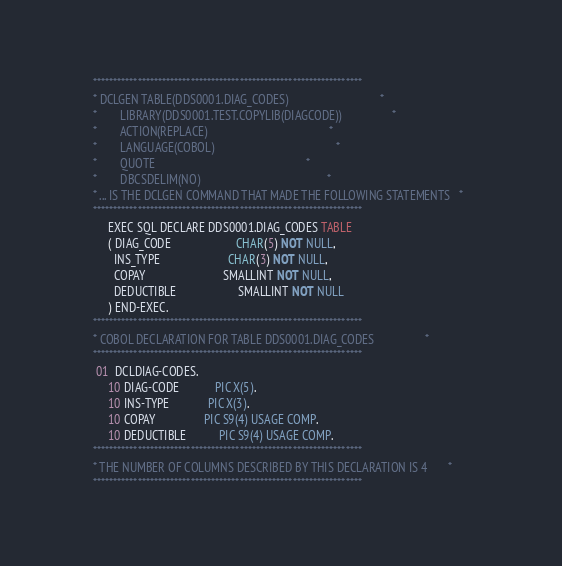<code> <loc_0><loc_0><loc_500><loc_500><_COBOL_>      ******************************************************************        
      * DCLGEN TABLE(DDS0001.DIAG_CODES)                               *        
      *        LIBRARY(DDS0001.TEST.COPYLIB(DIAGCODE))                 *        
      *        ACTION(REPLACE)                                         *        
      *        LANGUAGE(COBOL)                                         *        
      *        QUOTE                                                   *        
      *        DBCSDELIM(NO)                                           *        
      * ... IS THE DCLGEN COMMAND THAT MADE THE FOLLOWING STATEMENTS   *        
      ******************************************************************        
           EXEC SQL DECLARE DDS0001.DIAG_CODES TABLE                            
           ( DIAG_CODE                      CHAR(5) NOT NULL,                   
             INS_TYPE                       CHAR(3) NOT NULL,                   
             COPAY                          SMALLINT NOT NULL,                  
             DEDUCTIBLE                     SMALLINT NOT NULL                   
           ) END-EXEC.                                                          
      ******************************************************************        
      * COBOL DECLARATION FOR TABLE DDS0001.DIAG_CODES                 *        
      ******************************************************************        
       01  DCLDIAG-CODES.                                                       
           10 DIAG-CODE            PIC X(5).                                    
           10 INS-TYPE             PIC X(3).                                    
           10 COPAY                PIC S9(4) USAGE COMP.                        
           10 DEDUCTIBLE           PIC S9(4) USAGE COMP.                        
      ******************************************************************        
      * THE NUMBER OF COLUMNS DESCRIBED BY THIS DECLARATION IS 4       *        
      ******************************************************************        
</code> 